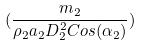Convert formula to latex. <formula><loc_0><loc_0><loc_500><loc_500>( \frac { m _ { 2 } } { \rho _ { 2 } a _ { 2 } D _ { 2 } ^ { 2 } C o s ( \alpha _ { 2 } ) } )</formula> 